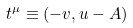<formula> <loc_0><loc_0><loc_500><loc_500>t ^ { \mu } \equiv ( - v , u - A )</formula> 